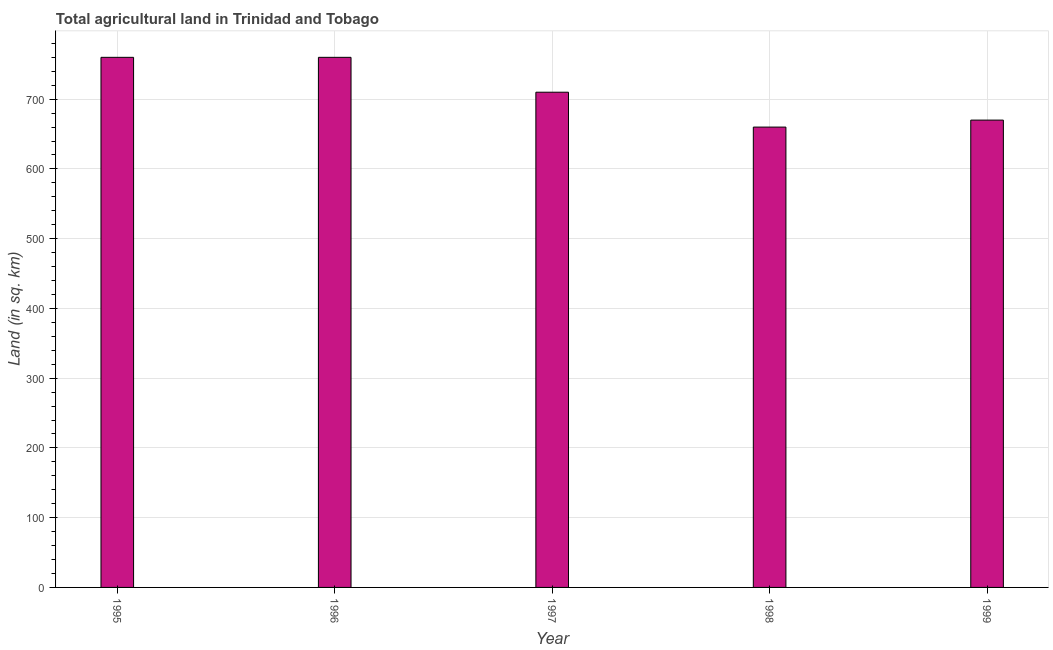Does the graph contain any zero values?
Provide a succinct answer. No. Does the graph contain grids?
Give a very brief answer. Yes. What is the title of the graph?
Your answer should be compact. Total agricultural land in Trinidad and Tobago. What is the label or title of the X-axis?
Provide a short and direct response. Year. What is the label or title of the Y-axis?
Your response must be concise. Land (in sq. km). What is the agricultural land in 1998?
Offer a very short reply. 660. Across all years, what is the maximum agricultural land?
Ensure brevity in your answer.  760. Across all years, what is the minimum agricultural land?
Give a very brief answer. 660. What is the sum of the agricultural land?
Your response must be concise. 3560. What is the average agricultural land per year?
Offer a terse response. 712. What is the median agricultural land?
Provide a short and direct response. 710. In how many years, is the agricultural land greater than 100 sq. km?
Your answer should be very brief. 5. What is the ratio of the agricultural land in 1996 to that in 1998?
Give a very brief answer. 1.15. What is the difference between the highest and the lowest agricultural land?
Give a very brief answer. 100. In how many years, is the agricultural land greater than the average agricultural land taken over all years?
Give a very brief answer. 2. How many years are there in the graph?
Give a very brief answer. 5. What is the difference between two consecutive major ticks on the Y-axis?
Give a very brief answer. 100. What is the Land (in sq. km) in 1995?
Give a very brief answer. 760. What is the Land (in sq. km) of 1996?
Your response must be concise. 760. What is the Land (in sq. km) of 1997?
Keep it short and to the point. 710. What is the Land (in sq. km) of 1998?
Your response must be concise. 660. What is the Land (in sq. km) of 1999?
Your response must be concise. 670. What is the difference between the Land (in sq. km) in 1995 and 1997?
Your answer should be compact. 50. What is the difference between the Land (in sq. km) in 1996 and 1997?
Keep it short and to the point. 50. What is the difference between the Land (in sq. km) in 1996 and 1998?
Your answer should be very brief. 100. What is the ratio of the Land (in sq. km) in 1995 to that in 1996?
Give a very brief answer. 1. What is the ratio of the Land (in sq. km) in 1995 to that in 1997?
Make the answer very short. 1.07. What is the ratio of the Land (in sq. km) in 1995 to that in 1998?
Make the answer very short. 1.15. What is the ratio of the Land (in sq. km) in 1995 to that in 1999?
Your answer should be compact. 1.13. What is the ratio of the Land (in sq. km) in 1996 to that in 1997?
Provide a short and direct response. 1.07. What is the ratio of the Land (in sq. km) in 1996 to that in 1998?
Provide a short and direct response. 1.15. What is the ratio of the Land (in sq. km) in 1996 to that in 1999?
Your answer should be very brief. 1.13. What is the ratio of the Land (in sq. km) in 1997 to that in 1998?
Make the answer very short. 1.08. What is the ratio of the Land (in sq. km) in 1997 to that in 1999?
Offer a terse response. 1.06. 